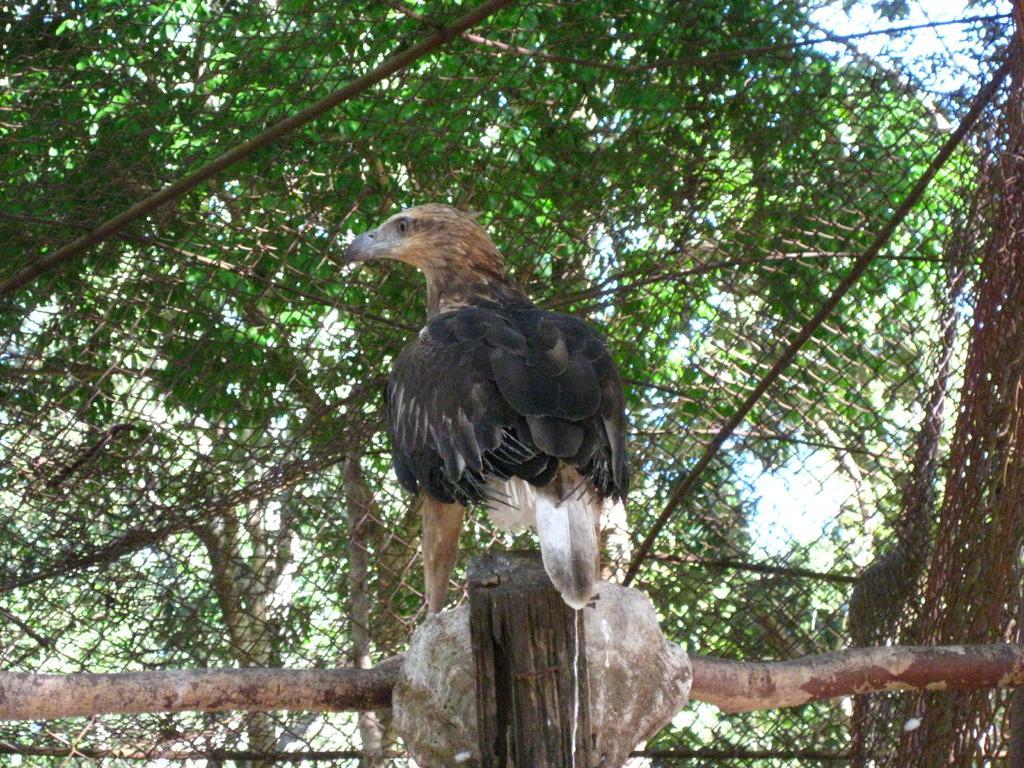In one or two sentences, can you explain what this image depicts? In this image we can see a bird standing on the wooden rod and in the background we have trees. 